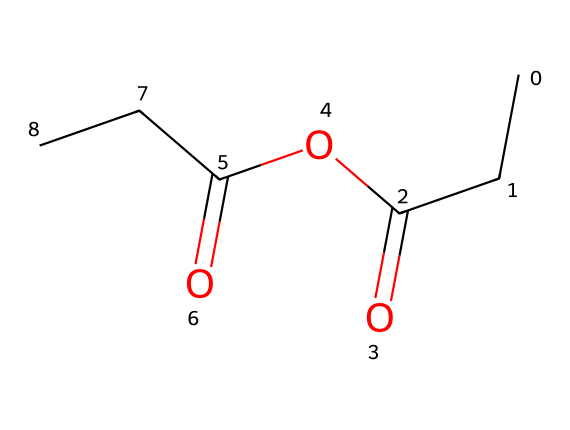What is the molecular formula of propionic anhydride? By analyzing the SMILES representation, we identify the carbon (C), hydrogen (H), and oxygen (O) atoms present. Counting the atoms yields 6 carbon atoms, 10 hydrogen atoms, and 2 oxygen atoms. Combining these gives the molecular formula C6H10O2.
Answer: C6H10O2 How many carbon atoms are present in propionic anhydride? The SMILES structure indicates a chain of carbon atoms, and counting these reveals 6 distinct carbon atoms present in the structure.
Answer: 6 How many oxygen atoms are present in propionic anhydride? The SMILES structure shows two occurrences of the oxygen atom, both of which can be identified by the 'O' characters in the representation.
Answer: 2 What type of functional groups are present in propionic anhydride? Analyzing the structure, we find that this molecule contains anhydride functional groups indicated by the presence of carbonyl (C=O) groups adjacent to the oxygen atom. This means there are anhydride functionalities in the compound.
Answer: anhydride What is the connectivity pattern of the carbon atoms in propionic anhydride? Referring to the SMILES structure, we see that the carbon atoms are connected in a linear arrangement with a carbonyl at each end and an ether-like bond between the two carbonyls, indicative of a symmetrical structure.
Answer: linear arrangement How many carbonyl groups are present in propionic anhydride? Examining the SMILES representation, we identify two carbonyl groups (C=O) resulting from the anhydride structure. Each carbonyl involves a carbon atom double-bonded to an oxygen atom.
Answer: 2 Is propionic anhydride a saturated or unsaturated compound? The presence of carbon-carbon single bonds and carbonyl groups suggest that there are no double bonds between carbon atoms, indicating it is a saturated compound.
Answer: saturated 